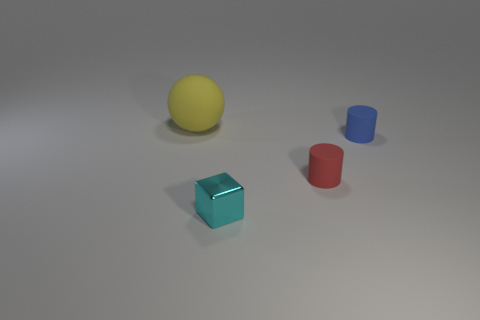Is there any other thing that has the same shape as the tiny cyan thing?
Provide a succinct answer. No. What is the material of the thing left of the cyan metal object?
Your response must be concise. Rubber. Are there any cyan metallic things that have the same shape as the red thing?
Offer a very short reply. No. How many yellow objects are the same shape as the small cyan thing?
Offer a very short reply. 0. Is the size of the cylinder in front of the blue rubber cylinder the same as the object that is on the left side of the metal object?
Provide a short and direct response. No. The rubber object behind the matte cylinder behind the small red rubber object is what shape?
Your answer should be compact. Sphere. Are there an equal number of tiny red things that are left of the cyan metallic thing and large red rubber objects?
Keep it short and to the point. Yes. The cylinder on the left side of the tiny cylinder that is behind the rubber cylinder in front of the blue matte thing is made of what material?
Offer a very short reply. Rubber. Are there any brown matte cubes that have the same size as the yellow object?
Your answer should be very brief. No. The tiny blue object has what shape?
Ensure brevity in your answer.  Cylinder. 